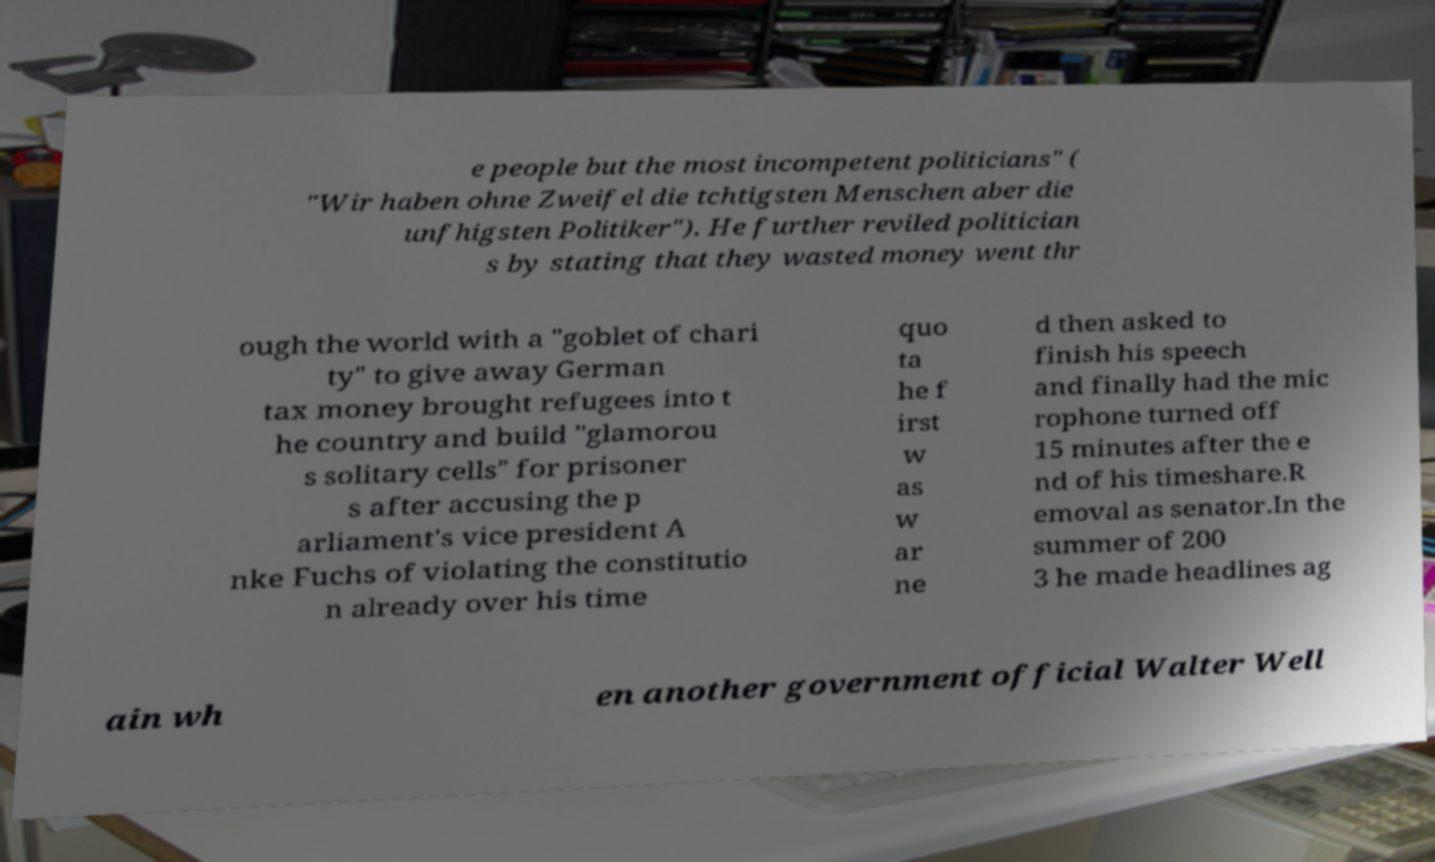Please read and relay the text visible in this image. What does it say? e people but the most incompetent politicians" ( "Wir haben ohne Zweifel die tchtigsten Menschen aber die unfhigsten Politiker"). He further reviled politician s by stating that they wasted money went thr ough the world with a "goblet of chari ty" to give away German tax money brought refugees into t he country and build "glamorou s solitary cells" for prisoner s after accusing the p arliament's vice president A nke Fuchs of violating the constitutio n already over his time quo ta he f irst w as w ar ne d then asked to finish his speech and finally had the mic rophone turned off 15 minutes after the e nd of his timeshare.R emoval as senator.In the summer of 200 3 he made headlines ag ain wh en another government official Walter Well 